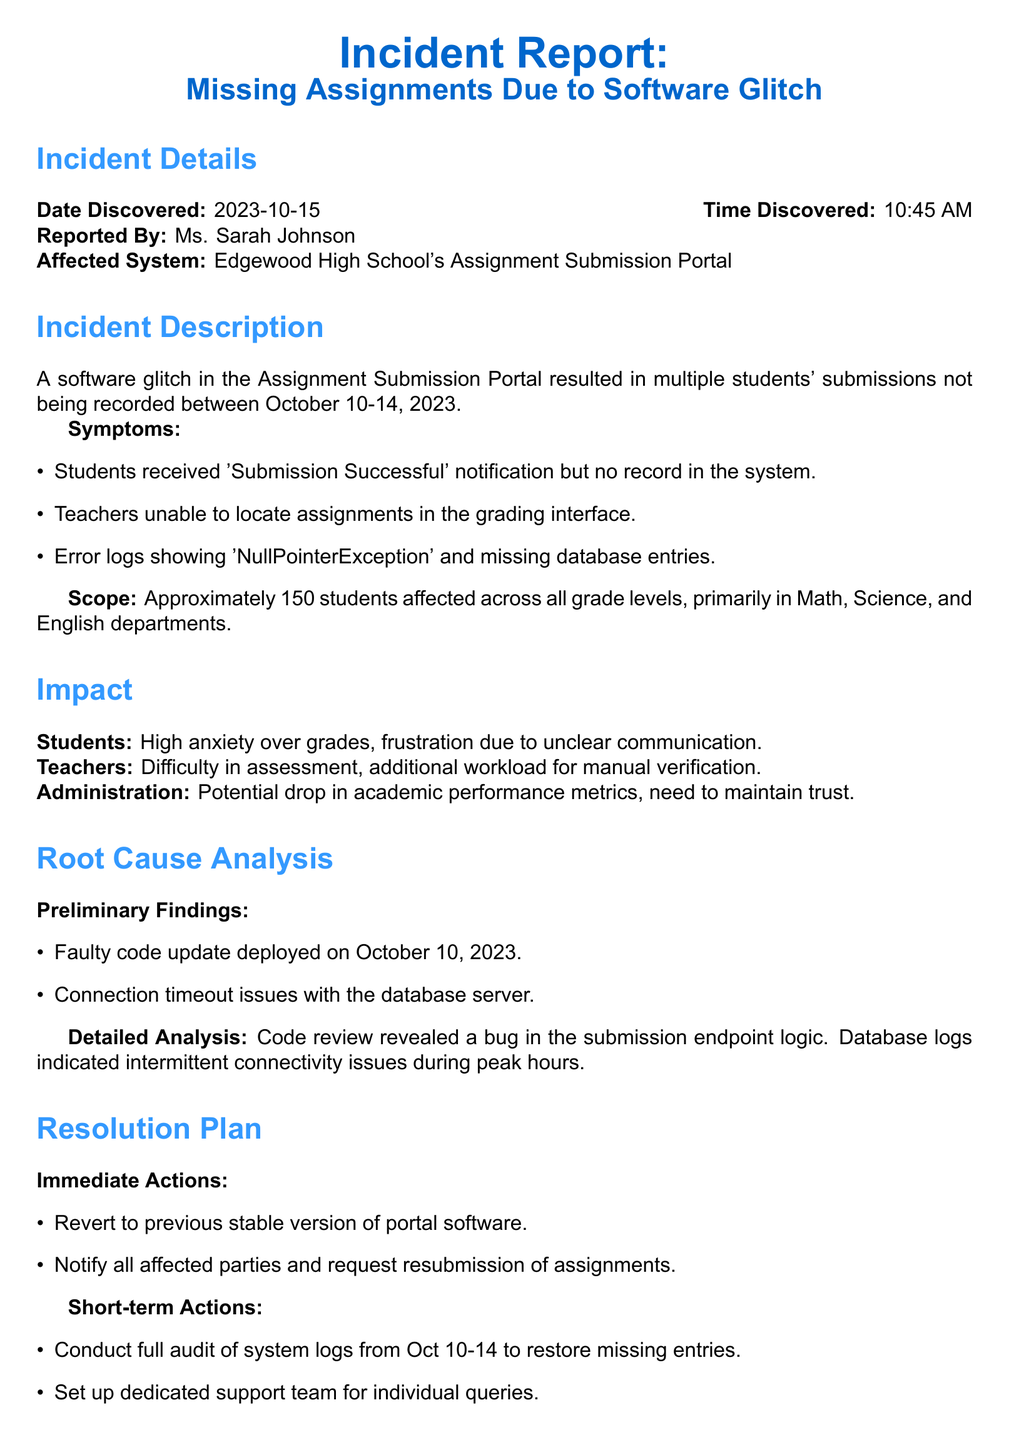What is the date the incident was discovered? The date the incident was discovered is stated in the document as October 15, 2023.
Answer: October 15, 2023 Who reported the incident? The document states that Ms. Sarah Johnson reported the incident.
Answer: Ms. Sarah Johnson What was the affected system? The document specifies that the affected system was Edgewood High School's Assignment Submission Portal.
Answer: Edgewood High School's Assignment Submission Portal How many students were affected by the incident? According to the document, approximately 150 students were affected across all grade levels.
Answer: Approximately 150 students What bug was identified in the preliminary findings? The document indicates that a faulty code update was the identified bug.
Answer: Faulty code update What immediate action was taken in response to the incident? The document lists reverting to the previous stable version of portal software as the immediate action taken.
Answer: Revert to previous stable version of portal software What error was indicated in the logs? The error logs showed 'NullPointerException' during the incident.
Answer: NullPointerException What are the long-term actions suggested? The document mentions implementing a robust testing protocol for future updates as one of the long-term actions.
Answer: Implement robust testing protocol for future updates What is the responsibility assigned for this incident? The document states that Mark Davies, IT Director, is responsible for the incident.
Answer: Mark Davies, IT Director 